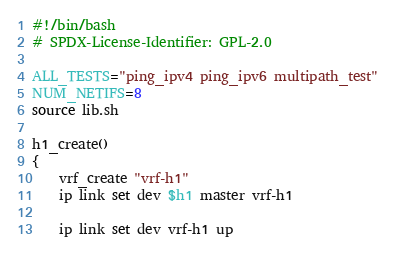<code> <loc_0><loc_0><loc_500><loc_500><_Bash_>#!/bin/bash
# SPDX-License-Identifier: GPL-2.0

ALL_TESTS="ping_ipv4 ping_ipv6 multipath_test"
NUM_NETIFS=8
source lib.sh

h1_create()
{
	vrf_create "vrf-h1"
	ip link set dev $h1 master vrf-h1

	ip link set dev vrf-h1 up</code> 